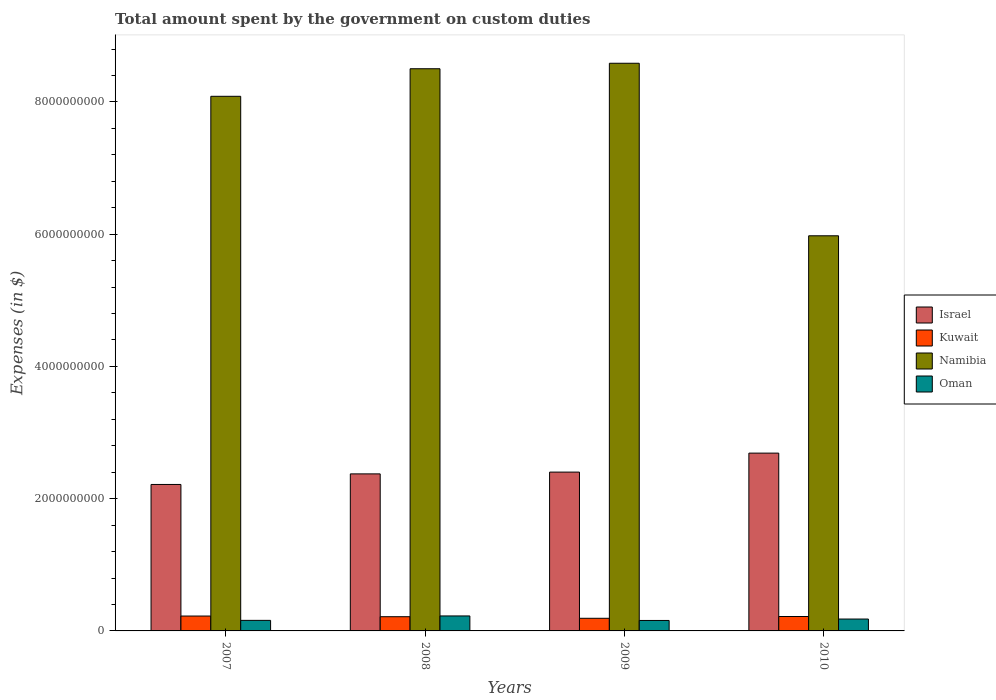How many different coloured bars are there?
Your response must be concise. 4. How many groups of bars are there?
Make the answer very short. 4. Are the number of bars on each tick of the X-axis equal?
Make the answer very short. Yes. How many bars are there on the 1st tick from the left?
Make the answer very short. 4. How many bars are there on the 1st tick from the right?
Ensure brevity in your answer.  4. What is the label of the 1st group of bars from the left?
Offer a very short reply. 2007. In how many cases, is the number of bars for a given year not equal to the number of legend labels?
Keep it short and to the point. 0. What is the amount spent on custom duties by the government in Kuwait in 2010?
Offer a terse response. 2.18e+08. Across all years, what is the maximum amount spent on custom duties by the government in Namibia?
Your response must be concise. 8.59e+09. Across all years, what is the minimum amount spent on custom duties by the government in Oman?
Offer a terse response. 1.58e+08. In which year was the amount spent on custom duties by the government in Kuwait maximum?
Your answer should be compact. 2007. In which year was the amount spent on custom duties by the government in Oman minimum?
Ensure brevity in your answer.  2009. What is the total amount spent on custom duties by the government in Namibia in the graph?
Your answer should be compact. 3.11e+1. What is the difference between the amount spent on custom duties by the government in Israel in 2008 and that in 2009?
Offer a terse response. -2.70e+07. What is the difference between the amount spent on custom duties by the government in Kuwait in 2007 and the amount spent on custom duties by the government in Namibia in 2010?
Your answer should be compact. -5.75e+09. What is the average amount spent on custom duties by the government in Oman per year?
Offer a terse response. 1.81e+08. In the year 2007, what is the difference between the amount spent on custom duties by the government in Kuwait and amount spent on custom duties by the government in Namibia?
Keep it short and to the point. -7.86e+09. What is the ratio of the amount spent on custom duties by the government in Namibia in 2009 to that in 2010?
Your response must be concise. 1.44. Is the difference between the amount spent on custom duties by the government in Kuwait in 2008 and 2009 greater than the difference between the amount spent on custom duties by the government in Namibia in 2008 and 2009?
Keep it short and to the point. Yes. What is the difference between the highest and the second highest amount spent on custom duties by the government in Israel?
Your answer should be very brief. 2.87e+08. What is the difference between the highest and the lowest amount spent on custom duties by the government in Oman?
Provide a succinct answer. 6.85e+07. In how many years, is the amount spent on custom duties by the government in Oman greater than the average amount spent on custom duties by the government in Oman taken over all years?
Offer a very short reply. 1. Is the sum of the amount spent on custom duties by the government in Namibia in 2008 and 2010 greater than the maximum amount spent on custom duties by the government in Oman across all years?
Your answer should be compact. Yes. What does the 3rd bar from the left in 2009 represents?
Provide a succinct answer. Namibia. What does the 1st bar from the right in 2010 represents?
Provide a succinct answer. Oman. Is it the case that in every year, the sum of the amount spent on custom duties by the government in Namibia and amount spent on custom duties by the government in Oman is greater than the amount spent on custom duties by the government in Kuwait?
Provide a succinct answer. Yes. What is the difference between two consecutive major ticks on the Y-axis?
Keep it short and to the point. 2.00e+09. Are the values on the major ticks of Y-axis written in scientific E-notation?
Provide a succinct answer. No. Does the graph contain grids?
Keep it short and to the point. No. Where does the legend appear in the graph?
Keep it short and to the point. Center right. How are the legend labels stacked?
Provide a succinct answer. Vertical. What is the title of the graph?
Provide a succinct answer. Total amount spent by the government on custom duties. What is the label or title of the Y-axis?
Your answer should be very brief. Expenses (in $). What is the Expenses (in $) of Israel in 2007?
Your response must be concise. 2.22e+09. What is the Expenses (in $) in Kuwait in 2007?
Keep it short and to the point. 2.25e+08. What is the Expenses (in $) of Namibia in 2007?
Provide a short and direct response. 8.09e+09. What is the Expenses (in $) in Oman in 2007?
Offer a terse response. 1.60e+08. What is the Expenses (in $) of Israel in 2008?
Your response must be concise. 2.38e+09. What is the Expenses (in $) in Kuwait in 2008?
Your answer should be very brief. 2.15e+08. What is the Expenses (in $) in Namibia in 2008?
Give a very brief answer. 8.50e+09. What is the Expenses (in $) in Oman in 2008?
Your answer should be very brief. 2.27e+08. What is the Expenses (in $) of Israel in 2009?
Ensure brevity in your answer.  2.40e+09. What is the Expenses (in $) in Kuwait in 2009?
Your answer should be very brief. 1.91e+08. What is the Expenses (in $) in Namibia in 2009?
Offer a very short reply. 8.59e+09. What is the Expenses (in $) of Oman in 2009?
Make the answer very short. 1.58e+08. What is the Expenses (in $) in Israel in 2010?
Make the answer very short. 2.69e+09. What is the Expenses (in $) of Kuwait in 2010?
Give a very brief answer. 2.18e+08. What is the Expenses (in $) in Namibia in 2010?
Ensure brevity in your answer.  5.98e+09. What is the Expenses (in $) in Oman in 2010?
Your response must be concise. 1.80e+08. Across all years, what is the maximum Expenses (in $) of Israel?
Your answer should be very brief. 2.69e+09. Across all years, what is the maximum Expenses (in $) of Kuwait?
Your response must be concise. 2.25e+08. Across all years, what is the maximum Expenses (in $) of Namibia?
Give a very brief answer. 8.59e+09. Across all years, what is the maximum Expenses (in $) in Oman?
Ensure brevity in your answer.  2.27e+08. Across all years, what is the minimum Expenses (in $) in Israel?
Your answer should be very brief. 2.22e+09. Across all years, what is the minimum Expenses (in $) in Kuwait?
Provide a short and direct response. 1.91e+08. Across all years, what is the minimum Expenses (in $) in Namibia?
Offer a terse response. 5.98e+09. Across all years, what is the minimum Expenses (in $) in Oman?
Your answer should be very brief. 1.58e+08. What is the total Expenses (in $) of Israel in the graph?
Your answer should be compact. 9.68e+09. What is the total Expenses (in $) of Kuwait in the graph?
Your response must be concise. 8.49e+08. What is the total Expenses (in $) in Namibia in the graph?
Make the answer very short. 3.11e+1. What is the total Expenses (in $) in Oman in the graph?
Offer a very short reply. 7.24e+08. What is the difference between the Expenses (in $) of Israel in 2007 and that in 2008?
Provide a short and direct response. -1.60e+08. What is the difference between the Expenses (in $) of Namibia in 2007 and that in 2008?
Your answer should be compact. -4.17e+08. What is the difference between the Expenses (in $) in Oman in 2007 and that in 2008?
Give a very brief answer. -6.70e+07. What is the difference between the Expenses (in $) in Israel in 2007 and that in 2009?
Provide a short and direct response. -1.87e+08. What is the difference between the Expenses (in $) in Kuwait in 2007 and that in 2009?
Ensure brevity in your answer.  3.40e+07. What is the difference between the Expenses (in $) of Namibia in 2007 and that in 2009?
Ensure brevity in your answer.  -5.00e+08. What is the difference between the Expenses (in $) of Oman in 2007 and that in 2009?
Your response must be concise. 1.50e+06. What is the difference between the Expenses (in $) in Israel in 2007 and that in 2010?
Offer a terse response. -4.74e+08. What is the difference between the Expenses (in $) in Namibia in 2007 and that in 2010?
Keep it short and to the point. 2.11e+09. What is the difference between the Expenses (in $) of Oman in 2007 and that in 2010?
Keep it short and to the point. -2.00e+07. What is the difference between the Expenses (in $) in Israel in 2008 and that in 2009?
Give a very brief answer. -2.70e+07. What is the difference between the Expenses (in $) in Kuwait in 2008 and that in 2009?
Provide a short and direct response. 2.40e+07. What is the difference between the Expenses (in $) in Namibia in 2008 and that in 2009?
Your answer should be compact. -8.30e+07. What is the difference between the Expenses (in $) in Oman in 2008 and that in 2009?
Give a very brief answer. 6.85e+07. What is the difference between the Expenses (in $) in Israel in 2008 and that in 2010?
Give a very brief answer. -3.14e+08. What is the difference between the Expenses (in $) of Kuwait in 2008 and that in 2010?
Offer a very short reply. -3.00e+06. What is the difference between the Expenses (in $) of Namibia in 2008 and that in 2010?
Ensure brevity in your answer.  2.53e+09. What is the difference between the Expenses (in $) of Oman in 2008 and that in 2010?
Make the answer very short. 4.70e+07. What is the difference between the Expenses (in $) of Israel in 2009 and that in 2010?
Keep it short and to the point. -2.87e+08. What is the difference between the Expenses (in $) of Kuwait in 2009 and that in 2010?
Your answer should be very brief. -2.70e+07. What is the difference between the Expenses (in $) in Namibia in 2009 and that in 2010?
Ensure brevity in your answer.  2.61e+09. What is the difference between the Expenses (in $) in Oman in 2009 and that in 2010?
Give a very brief answer. -2.15e+07. What is the difference between the Expenses (in $) in Israel in 2007 and the Expenses (in $) in Kuwait in 2008?
Make the answer very short. 2.00e+09. What is the difference between the Expenses (in $) of Israel in 2007 and the Expenses (in $) of Namibia in 2008?
Offer a very short reply. -6.29e+09. What is the difference between the Expenses (in $) in Israel in 2007 and the Expenses (in $) in Oman in 2008?
Offer a terse response. 1.99e+09. What is the difference between the Expenses (in $) in Kuwait in 2007 and the Expenses (in $) in Namibia in 2008?
Offer a terse response. -8.28e+09. What is the difference between the Expenses (in $) of Kuwait in 2007 and the Expenses (in $) of Oman in 2008?
Offer a very short reply. -1.60e+06. What is the difference between the Expenses (in $) of Namibia in 2007 and the Expenses (in $) of Oman in 2008?
Offer a terse response. 7.86e+09. What is the difference between the Expenses (in $) in Israel in 2007 and the Expenses (in $) in Kuwait in 2009?
Ensure brevity in your answer.  2.02e+09. What is the difference between the Expenses (in $) of Israel in 2007 and the Expenses (in $) of Namibia in 2009?
Provide a succinct answer. -6.37e+09. What is the difference between the Expenses (in $) in Israel in 2007 and the Expenses (in $) in Oman in 2009?
Offer a terse response. 2.06e+09. What is the difference between the Expenses (in $) of Kuwait in 2007 and the Expenses (in $) of Namibia in 2009?
Offer a very short reply. -8.36e+09. What is the difference between the Expenses (in $) of Kuwait in 2007 and the Expenses (in $) of Oman in 2009?
Offer a very short reply. 6.69e+07. What is the difference between the Expenses (in $) of Namibia in 2007 and the Expenses (in $) of Oman in 2009?
Give a very brief answer. 7.93e+09. What is the difference between the Expenses (in $) in Israel in 2007 and the Expenses (in $) in Kuwait in 2010?
Your answer should be compact. 2.00e+09. What is the difference between the Expenses (in $) in Israel in 2007 and the Expenses (in $) in Namibia in 2010?
Provide a short and direct response. -3.76e+09. What is the difference between the Expenses (in $) of Israel in 2007 and the Expenses (in $) of Oman in 2010?
Offer a terse response. 2.04e+09. What is the difference between the Expenses (in $) of Kuwait in 2007 and the Expenses (in $) of Namibia in 2010?
Offer a terse response. -5.75e+09. What is the difference between the Expenses (in $) in Kuwait in 2007 and the Expenses (in $) in Oman in 2010?
Provide a succinct answer. 4.54e+07. What is the difference between the Expenses (in $) in Namibia in 2007 and the Expenses (in $) in Oman in 2010?
Give a very brief answer. 7.91e+09. What is the difference between the Expenses (in $) in Israel in 2008 and the Expenses (in $) in Kuwait in 2009?
Offer a terse response. 2.18e+09. What is the difference between the Expenses (in $) of Israel in 2008 and the Expenses (in $) of Namibia in 2009?
Provide a short and direct response. -6.21e+09. What is the difference between the Expenses (in $) of Israel in 2008 and the Expenses (in $) of Oman in 2009?
Keep it short and to the point. 2.22e+09. What is the difference between the Expenses (in $) of Kuwait in 2008 and the Expenses (in $) of Namibia in 2009?
Keep it short and to the point. -8.37e+09. What is the difference between the Expenses (in $) in Kuwait in 2008 and the Expenses (in $) in Oman in 2009?
Offer a very short reply. 5.69e+07. What is the difference between the Expenses (in $) in Namibia in 2008 and the Expenses (in $) in Oman in 2009?
Give a very brief answer. 8.34e+09. What is the difference between the Expenses (in $) in Israel in 2008 and the Expenses (in $) in Kuwait in 2010?
Your response must be concise. 2.16e+09. What is the difference between the Expenses (in $) in Israel in 2008 and the Expenses (in $) in Namibia in 2010?
Ensure brevity in your answer.  -3.60e+09. What is the difference between the Expenses (in $) in Israel in 2008 and the Expenses (in $) in Oman in 2010?
Keep it short and to the point. 2.20e+09. What is the difference between the Expenses (in $) in Kuwait in 2008 and the Expenses (in $) in Namibia in 2010?
Give a very brief answer. -5.76e+09. What is the difference between the Expenses (in $) in Kuwait in 2008 and the Expenses (in $) in Oman in 2010?
Provide a succinct answer. 3.54e+07. What is the difference between the Expenses (in $) in Namibia in 2008 and the Expenses (in $) in Oman in 2010?
Provide a short and direct response. 8.32e+09. What is the difference between the Expenses (in $) in Israel in 2009 and the Expenses (in $) in Kuwait in 2010?
Provide a succinct answer. 2.18e+09. What is the difference between the Expenses (in $) of Israel in 2009 and the Expenses (in $) of Namibia in 2010?
Give a very brief answer. -3.57e+09. What is the difference between the Expenses (in $) in Israel in 2009 and the Expenses (in $) in Oman in 2010?
Your response must be concise. 2.22e+09. What is the difference between the Expenses (in $) in Kuwait in 2009 and the Expenses (in $) in Namibia in 2010?
Your answer should be compact. -5.78e+09. What is the difference between the Expenses (in $) of Kuwait in 2009 and the Expenses (in $) of Oman in 2010?
Your answer should be compact. 1.14e+07. What is the difference between the Expenses (in $) of Namibia in 2009 and the Expenses (in $) of Oman in 2010?
Your answer should be compact. 8.41e+09. What is the average Expenses (in $) of Israel per year?
Give a very brief answer. 2.42e+09. What is the average Expenses (in $) of Kuwait per year?
Your answer should be compact. 2.12e+08. What is the average Expenses (in $) of Namibia per year?
Your answer should be very brief. 7.79e+09. What is the average Expenses (in $) in Oman per year?
Make the answer very short. 1.81e+08. In the year 2007, what is the difference between the Expenses (in $) of Israel and Expenses (in $) of Kuwait?
Keep it short and to the point. 1.99e+09. In the year 2007, what is the difference between the Expenses (in $) in Israel and Expenses (in $) in Namibia?
Provide a short and direct response. -5.87e+09. In the year 2007, what is the difference between the Expenses (in $) of Israel and Expenses (in $) of Oman?
Give a very brief answer. 2.06e+09. In the year 2007, what is the difference between the Expenses (in $) of Kuwait and Expenses (in $) of Namibia?
Provide a succinct answer. -7.86e+09. In the year 2007, what is the difference between the Expenses (in $) of Kuwait and Expenses (in $) of Oman?
Make the answer very short. 6.54e+07. In the year 2007, what is the difference between the Expenses (in $) in Namibia and Expenses (in $) in Oman?
Keep it short and to the point. 7.93e+09. In the year 2008, what is the difference between the Expenses (in $) of Israel and Expenses (in $) of Kuwait?
Make the answer very short. 2.16e+09. In the year 2008, what is the difference between the Expenses (in $) of Israel and Expenses (in $) of Namibia?
Give a very brief answer. -6.13e+09. In the year 2008, what is the difference between the Expenses (in $) in Israel and Expenses (in $) in Oman?
Keep it short and to the point. 2.15e+09. In the year 2008, what is the difference between the Expenses (in $) in Kuwait and Expenses (in $) in Namibia?
Give a very brief answer. -8.29e+09. In the year 2008, what is the difference between the Expenses (in $) of Kuwait and Expenses (in $) of Oman?
Offer a terse response. -1.16e+07. In the year 2008, what is the difference between the Expenses (in $) in Namibia and Expenses (in $) in Oman?
Offer a terse response. 8.28e+09. In the year 2009, what is the difference between the Expenses (in $) of Israel and Expenses (in $) of Kuwait?
Your response must be concise. 2.21e+09. In the year 2009, what is the difference between the Expenses (in $) of Israel and Expenses (in $) of Namibia?
Provide a short and direct response. -6.18e+09. In the year 2009, what is the difference between the Expenses (in $) of Israel and Expenses (in $) of Oman?
Give a very brief answer. 2.24e+09. In the year 2009, what is the difference between the Expenses (in $) of Kuwait and Expenses (in $) of Namibia?
Your response must be concise. -8.39e+09. In the year 2009, what is the difference between the Expenses (in $) of Kuwait and Expenses (in $) of Oman?
Make the answer very short. 3.29e+07. In the year 2009, what is the difference between the Expenses (in $) of Namibia and Expenses (in $) of Oman?
Make the answer very short. 8.43e+09. In the year 2010, what is the difference between the Expenses (in $) of Israel and Expenses (in $) of Kuwait?
Ensure brevity in your answer.  2.47e+09. In the year 2010, what is the difference between the Expenses (in $) of Israel and Expenses (in $) of Namibia?
Give a very brief answer. -3.29e+09. In the year 2010, what is the difference between the Expenses (in $) in Israel and Expenses (in $) in Oman?
Provide a succinct answer. 2.51e+09. In the year 2010, what is the difference between the Expenses (in $) of Kuwait and Expenses (in $) of Namibia?
Offer a terse response. -5.76e+09. In the year 2010, what is the difference between the Expenses (in $) in Kuwait and Expenses (in $) in Oman?
Make the answer very short. 3.84e+07. In the year 2010, what is the difference between the Expenses (in $) in Namibia and Expenses (in $) in Oman?
Your answer should be compact. 5.80e+09. What is the ratio of the Expenses (in $) of Israel in 2007 to that in 2008?
Give a very brief answer. 0.93. What is the ratio of the Expenses (in $) in Kuwait in 2007 to that in 2008?
Your answer should be compact. 1.05. What is the ratio of the Expenses (in $) in Namibia in 2007 to that in 2008?
Provide a short and direct response. 0.95. What is the ratio of the Expenses (in $) of Oman in 2007 to that in 2008?
Ensure brevity in your answer.  0.7. What is the ratio of the Expenses (in $) in Israel in 2007 to that in 2009?
Make the answer very short. 0.92. What is the ratio of the Expenses (in $) in Kuwait in 2007 to that in 2009?
Give a very brief answer. 1.18. What is the ratio of the Expenses (in $) of Namibia in 2007 to that in 2009?
Offer a terse response. 0.94. What is the ratio of the Expenses (in $) of Oman in 2007 to that in 2009?
Provide a succinct answer. 1.01. What is the ratio of the Expenses (in $) of Israel in 2007 to that in 2010?
Ensure brevity in your answer.  0.82. What is the ratio of the Expenses (in $) in Kuwait in 2007 to that in 2010?
Offer a very short reply. 1.03. What is the ratio of the Expenses (in $) in Namibia in 2007 to that in 2010?
Ensure brevity in your answer.  1.35. What is the ratio of the Expenses (in $) of Oman in 2007 to that in 2010?
Your response must be concise. 0.89. What is the ratio of the Expenses (in $) in Israel in 2008 to that in 2009?
Provide a succinct answer. 0.99. What is the ratio of the Expenses (in $) in Kuwait in 2008 to that in 2009?
Make the answer very short. 1.13. What is the ratio of the Expenses (in $) of Namibia in 2008 to that in 2009?
Keep it short and to the point. 0.99. What is the ratio of the Expenses (in $) of Oman in 2008 to that in 2009?
Your answer should be very brief. 1.43. What is the ratio of the Expenses (in $) of Israel in 2008 to that in 2010?
Your answer should be very brief. 0.88. What is the ratio of the Expenses (in $) of Kuwait in 2008 to that in 2010?
Keep it short and to the point. 0.99. What is the ratio of the Expenses (in $) in Namibia in 2008 to that in 2010?
Provide a short and direct response. 1.42. What is the ratio of the Expenses (in $) of Oman in 2008 to that in 2010?
Your answer should be compact. 1.26. What is the ratio of the Expenses (in $) in Israel in 2009 to that in 2010?
Make the answer very short. 0.89. What is the ratio of the Expenses (in $) of Kuwait in 2009 to that in 2010?
Your answer should be compact. 0.88. What is the ratio of the Expenses (in $) in Namibia in 2009 to that in 2010?
Give a very brief answer. 1.44. What is the ratio of the Expenses (in $) in Oman in 2009 to that in 2010?
Keep it short and to the point. 0.88. What is the difference between the highest and the second highest Expenses (in $) of Israel?
Make the answer very short. 2.87e+08. What is the difference between the highest and the second highest Expenses (in $) in Namibia?
Your answer should be very brief. 8.30e+07. What is the difference between the highest and the second highest Expenses (in $) of Oman?
Provide a short and direct response. 4.70e+07. What is the difference between the highest and the lowest Expenses (in $) in Israel?
Your answer should be compact. 4.74e+08. What is the difference between the highest and the lowest Expenses (in $) of Kuwait?
Provide a short and direct response. 3.40e+07. What is the difference between the highest and the lowest Expenses (in $) of Namibia?
Give a very brief answer. 2.61e+09. What is the difference between the highest and the lowest Expenses (in $) in Oman?
Your answer should be compact. 6.85e+07. 